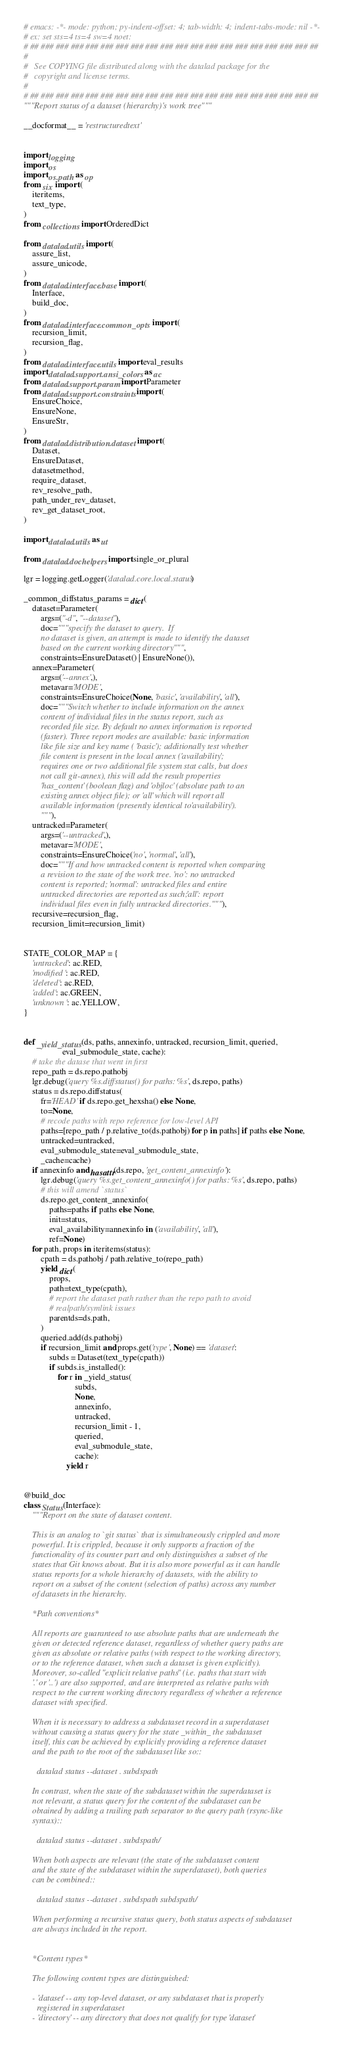Convert code to text. <code><loc_0><loc_0><loc_500><loc_500><_Python_># emacs: -*- mode: python; py-indent-offset: 4; tab-width: 4; indent-tabs-mode: nil -*-
# ex: set sts=4 ts=4 sw=4 noet:
# ## ### ### ### ### ### ### ### ### ### ### ### ### ### ### ### ### ### ### ##
#
#   See COPYING file distributed along with the datalad package for the
#   copyright and license terms.
#
# ## ### ### ### ### ### ### ### ### ### ### ### ### ### ### ### ### ### ### ##
"""Report status of a dataset (hierarchy)'s work tree"""

__docformat__ = 'restructuredtext'


import logging
import os
import os.path as op
from six import (
    iteritems,
    text_type,
)
from collections import OrderedDict

from datalad.utils import (
    assure_list,
    assure_unicode,
)
from datalad.interface.base import (
    Interface,
    build_doc,
)
from datalad.interface.common_opts import (
    recursion_limit,
    recursion_flag,
)
from datalad.interface.utils import eval_results
import datalad.support.ansi_colors as ac
from datalad.support.param import Parameter
from datalad.support.constraints import (
    EnsureChoice,
    EnsureNone,
    EnsureStr,
)
from datalad.distribution.dataset import (
    Dataset,
    EnsureDataset,
    datasetmethod,
    require_dataset,
    rev_resolve_path,
    path_under_rev_dataset,
    rev_get_dataset_root,
)

import datalad.utils as ut

from datalad.dochelpers import single_or_plural

lgr = logging.getLogger('datalad.core.local.status')

_common_diffstatus_params = dict(
    dataset=Parameter(
        args=("-d", "--dataset"),
        doc="""specify the dataset to query.  If
        no dataset is given, an attempt is made to identify the dataset
        based on the current working directory""",
        constraints=EnsureDataset() | EnsureNone()),
    annex=Parameter(
        args=('--annex',),
        metavar='MODE',
        constraints=EnsureChoice(None, 'basic', 'availability', 'all'),
        doc="""Switch whether to include information on the annex
        content of individual files in the status report, such as
        recorded file size. By default no annex information is reported
        (faster). Three report modes are available: basic information
        like file size and key name ('basic'); additionally test whether
        file content is present in the local annex ('availability';
        requires one or two additional file system stat calls, but does
        not call git-annex), this will add the result properties
        'has_content' (boolean flag) and 'objloc' (absolute path to an
        existing annex object file); or 'all' which will report all
        available information (presently identical to 'availability').
        """),
    untracked=Parameter(
        args=('--untracked',),
        metavar='MODE',
        constraints=EnsureChoice('no', 'normal', 'all'),
        doc="""If and how untracked content is reported when comparing
        a revision to the state of the work tree. 'no': no untracked
        content is reported; 'normal': untracked files and entire
        untracked directories are reported as such; 'all': report
        individual files even in fully untracked directories."""),
    recursive=recursion_flag,
    recursion_limit=recursion_limit)


STATE_COLOR_MAP = {
    'untracked': ac.RED,
    'modified': ac.RED,
    'deleted': ac.RED,
    'added': ac.GREEN,
    'unknown': ac.YELLOW,
}


def _yield_status(ds, paths, annexinfo, untracked, recursion_limit, queried,
                  eval_submodule_state, cache):
    # take the datase that went in first
    repo_path = ds.repo.pathobj
    lgr.debug('query %s.diffstatus() for paths: %s', ds.repo, paths)
    status = ds.repo.diffstatus(
        fr='HEAD' if ds.repo.get_hexsha() else None,
        to=None,
        # recode paths with repo reference for low-level API
        paths=[repo_path / p.relative_to(ds.pathobj) for p in paths] if paths else None,
        untracked=untracked,
        eval_submodule_state=eval_submodule_state,
        _cache=cache)
    if annexinfo and hasattr(ds.repo, 'get_content_annexinfo'):
        lgr.debug('query %s.get_content_annexinfo() for paths: %s', ds.repo, paths)
        # this will amend `status`
        ds.repo.get_content_annexinfo(
            paths=paths if paths else None,
            init=status,
            eval_availability=annexinfo in ('availability', 'all'),
            ref=None)
    for path, props in iteritems(status):
        cpath = ds.pathobj / path.relative_to(repo_path)
        yield dict(
            props,
            path=text_type(cpath),
            # report the dataset path rather than the repo path to avoid
            # realpath/symlink issues
            parentds=ds.path,
        )
        queried.add(ds.pathobj)
        if recursion_limit and props.get('type', None) == 'dataset':
            subds = Dataset(text_type(cpath))
            if subds.is_installed():
                for r in _yield_status(
                        subds,
                        None,
                        annexinfo,
                        untracked,
                        recursion_limit - 1,
                        queried,
                        eval_submodule_state,
                        cache):
                    yield r


@build_doc
class Status(Interface):
    """Report on the state of dataset content.

    This is an analog to `git status` that is simultaneously crippled and more
    powerful. It is crippled, because it only supports a fraction of the
    functionality of its counter part and only distinguishes a subset of the
    states that Git knows about. But it is also more powerful as it can handle
    status reports for a whole hierarchy of datasets, with the ability to
    report on a subset of the content (selection of paths) across any number
    of datasets in the hierarchy.

    *Path conventions*

    All reports are guaranteed to use absolute paths that are underneath the
    given or detected reference dataset, regardless of whether query paths are
    given as absolute or relative paths (with respect to the working directory,
    or to the reference dataset, when such a dataset is given explicitly).
    Moreover, so-called "explicit relative paths" (i.e. paths that start with
    '.' or '..') are also supported, and are interpreted as relative paths with
    respect to the current working directory regardless of whether a reference
    dataset with specified.

    When it is necessary to address a subdataset record in a superdataset
    without causing a status query for the state _within_ the subdataset
    itself, this can be achieved by explicitly providing a reference dataset
    and the path to the root of the subdataset like so::

      datalad status --dataset . subdspath

    In contrast, when the state of the subdataset within the superdataset is
    not relevant, a status query for the content of the subdataset can be
    obtained by adding a trailing path separator to the query path (rsync-like
    syntax)::

      datalad status --dataset . subdspath/

    When both aspects are relevant (the state of the subdataset content
    and the state of the subdataset within the superdataset), both queries
    can be combined::

      datalad status --dataset . subdspath subdspath/

    When performing a recursive status query, both status aspects of subdataset
    are always included in the report.


    *Content types*

    The following content types are distinguished:

    - 'dataset' -- any top-level dataset, or any subdataset that is properly
      registered in superdataset
    - 'directory' -- any directory that does not qualify for type 'dataset'</code> 